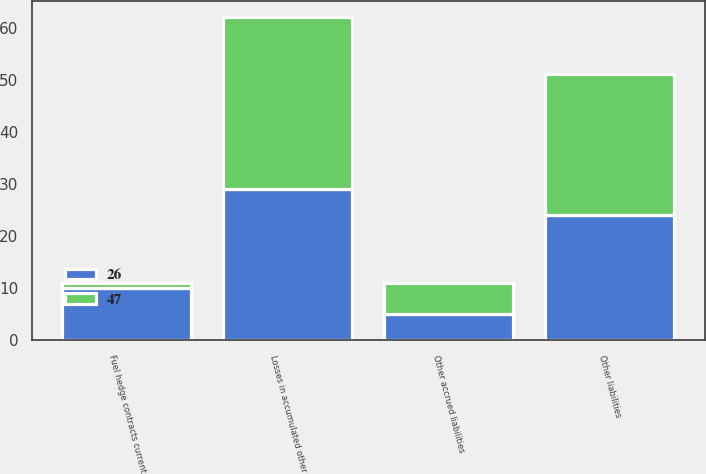Convert chart to OTSL. <chart><loc_0><loc_0><loc_500><loc_500><stacked_bar_chart><ecel><fcel>Fuel hedge contracts current<fcel>Other accrued liabilities<fcel>Other liabilities<fcel>Losses in accumulated other<nl><fcel>47<fcel>1<fcel>6<fcel>27<fcel>33<nl><fcel>26<fcel>10<fcel>5<fcel>24<fcel>29<nl></chart> 